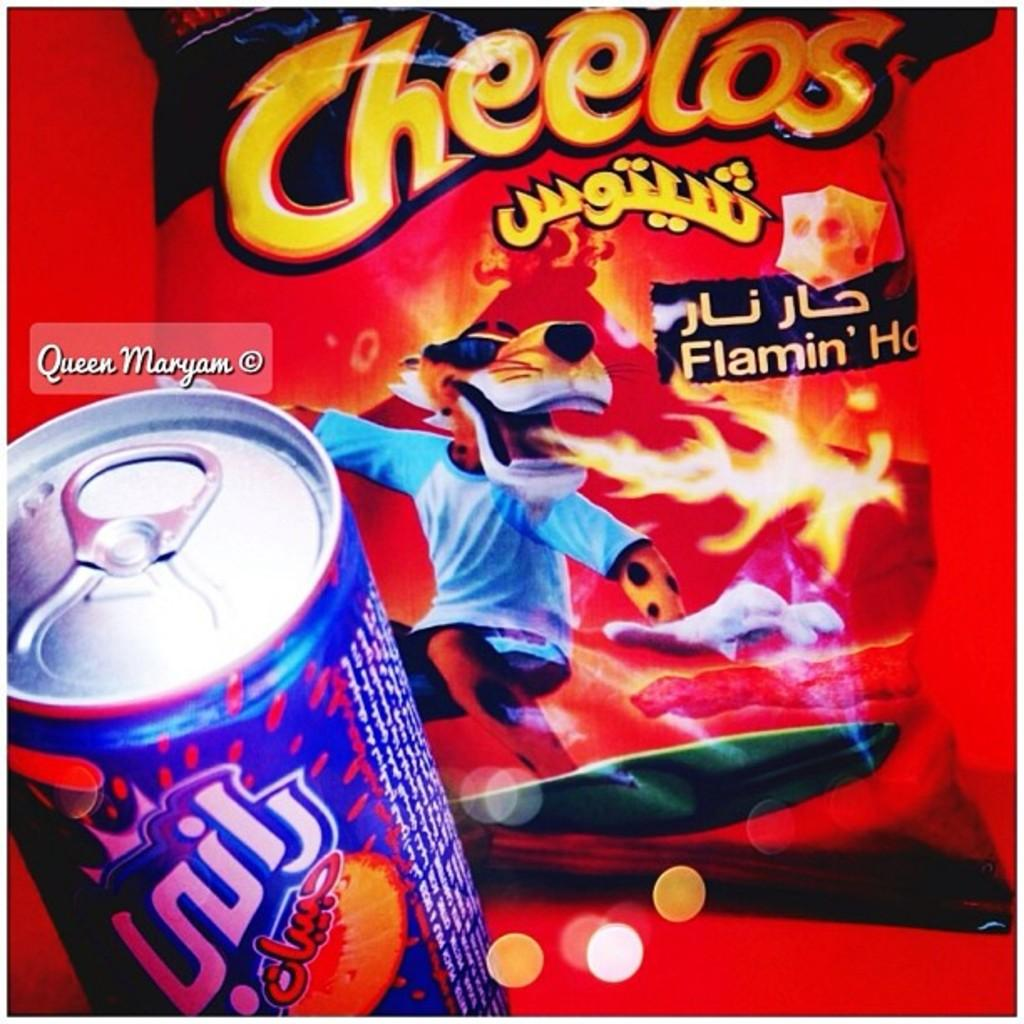<image>
Relay a brief, clear account of the picture shown. A bag of chips says Cheetos Flamin' Hot and a can of soda. 